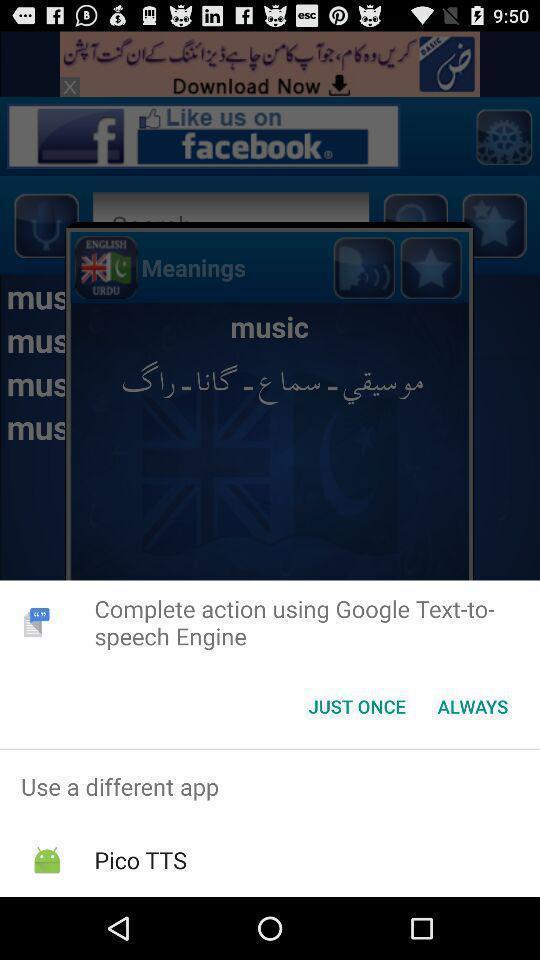Describe this image in words. Widget showing two text conversion options. 